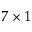<formula> <loc_0><loc_0><loc_500><loc_500>7 \times 1</formula> 